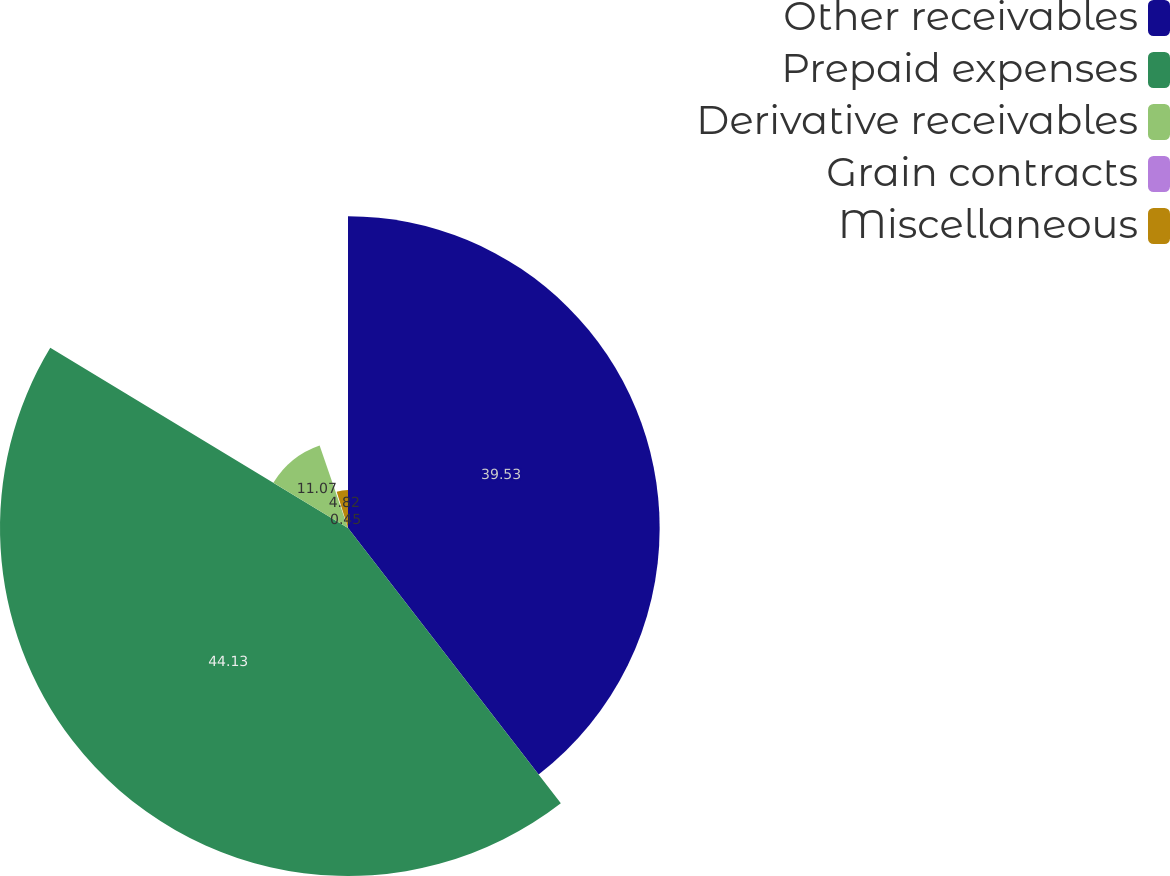<chart> <loc_0><loc_0><loc_500><loc_500><pie_chart><fcel>Other receivables<fcel>Prepaid expenses<fcel>Derivative receivables<fcel>Grain contracts<fcel>Miscellaneous<nl><fcel>39.53%<fcel>44.14%<fcel>11.07%<fcel>0.45%<fcel>4.82%<nl></chart> 